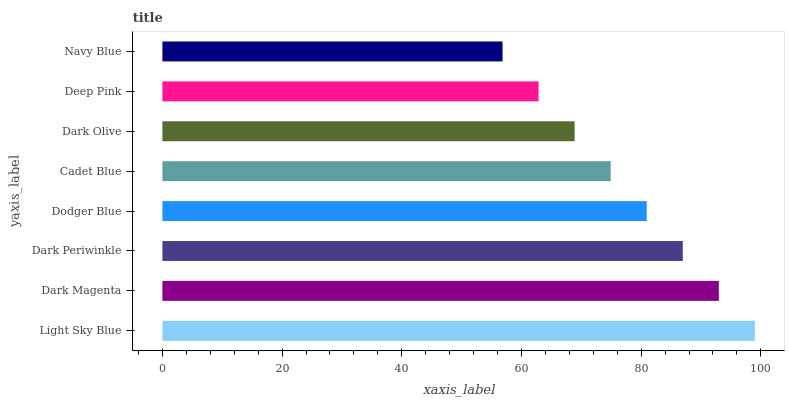Is Navy Blue the minimum?
Answer yes or no. Yes. Is Light Sky Blue the maximum?
Answer yes or no. Yes. Is Dark Magenta the minimum?
Answer yes or no. No. Is Dark Magenta the maximum?
Answer yes or no. No. Is Light Sky Blue greater than Dark Magenta?
Answer yes or no. Yes. Is Dark Magenta less than Light Sky Blue?
Answer yes or no. Yes. Is Dark Magenta greater than Light Sky Blue?
Answer yes or no. No. Is Light Sky Blue less than Dark Magenta?
Answer yes or no. No. Is Dodger Blue the high median?
Answer yes or no. Yes. Is Cadet Blue the low median?
Answer yes or no. Yes. Is Dark Magenta the high median?
Answer yes or no. No. Is Deep Pink the low median?
Answer yes or no. No. 